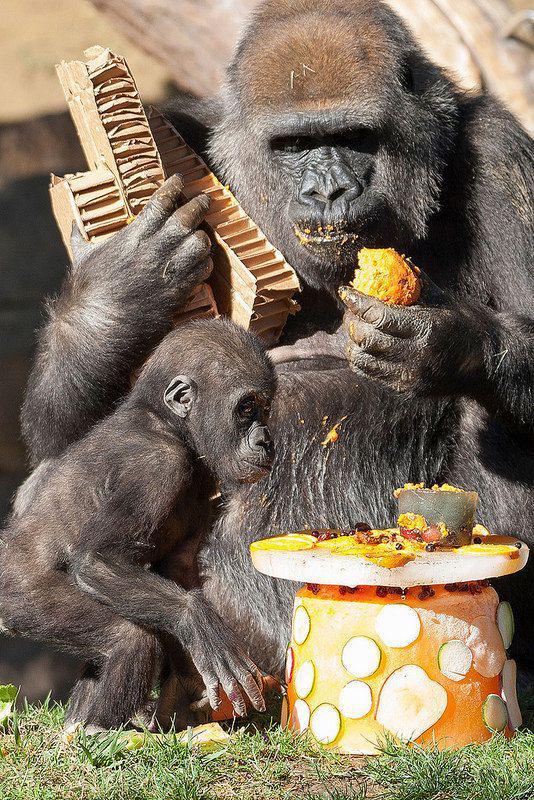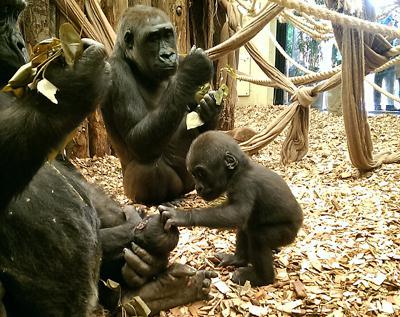The first image is the image on the left, the second image is the image on the right. For the images shown, is this caption "there are multiple gorillas sitting on logs in various sizes in front of a lasrge tree trunk" true? Answer yes or no. No. The first image is the image on the left, the second image is the image on the right. Evaluate the accuracy of this statement regarding the images: "One image shows multiple gorillas sitting on fallen logs in front of a massive tree trunk covered with twisted brown shapes.". Is it true? Answer yes or no. No. 